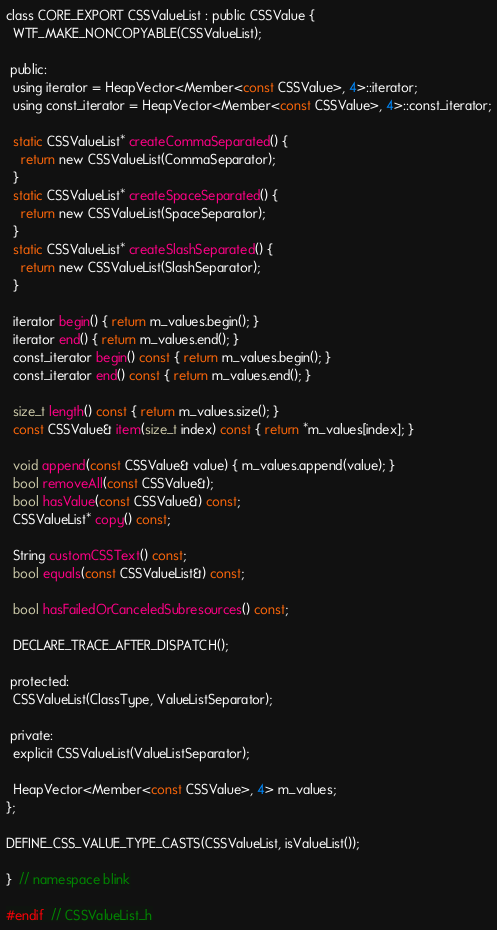Convert code to text. <code><loc_0><loc_0><loc_500><loc_500><_C_>class CORE_EXPORT CSSValueList : public CSSValue {
  WTF_MAKE_NONCOPYABLE(CSSValueList);

 public:
  using iterator = HeapVector<Member<const CSSValue>, 4>::iterator;
  using const_iterator = HeapVector<Member<const CSSValue>, 4>::const_iterator;

  static CSSValueList* createCommaSeparated() {
    return new CSSValueList(CommaSeparator);
  }
  static CSSValueList* createSpaceSeparated() {
    return new CSSValueList(SpaceSeparator);
  }
  static CSSValueList* createSlashSeparated() {
    return new CSSValueList(SlashSeparator);
  }

  iterator begin() { return m_values.begin(); }
  iterator end() { return m_values.end(); }
  const_iterator begin() const { return m_values.begin(); }
  const_iterator end() const { return m_values.end(); }

  size_t length() const { return m_values.size(); }
  const CSSValue& item(size_t index) const { return *m_values[index]; }

  void append(const CSSValue& value) { m_values.append(value); }
  bool removeAll(const CSSValue&);
  bool hasValue(const CSSValue&) const;
  CSSValueList* copy() const;

  String customCSSText() const;
  bool equals(const CSSValueList&) const;

  bool hasFailedOrCanceledSubresources() const;

  DECLARE_TRACE_AFTER_DISPATCH();

 protected:
  CSSValueList(ClassType, ValueListSeparator);

 private:
  explicit CSSValueList(ValueListSeparator);

  HeapVector<Member<const CSSValue>, 4> m_values;
};

DEFINE_CSS_VALUE_TYPE_CASTS(CSSValueList, isValueList());

}  // namespace blink

#endif  // CSSValueList_h
</code> 